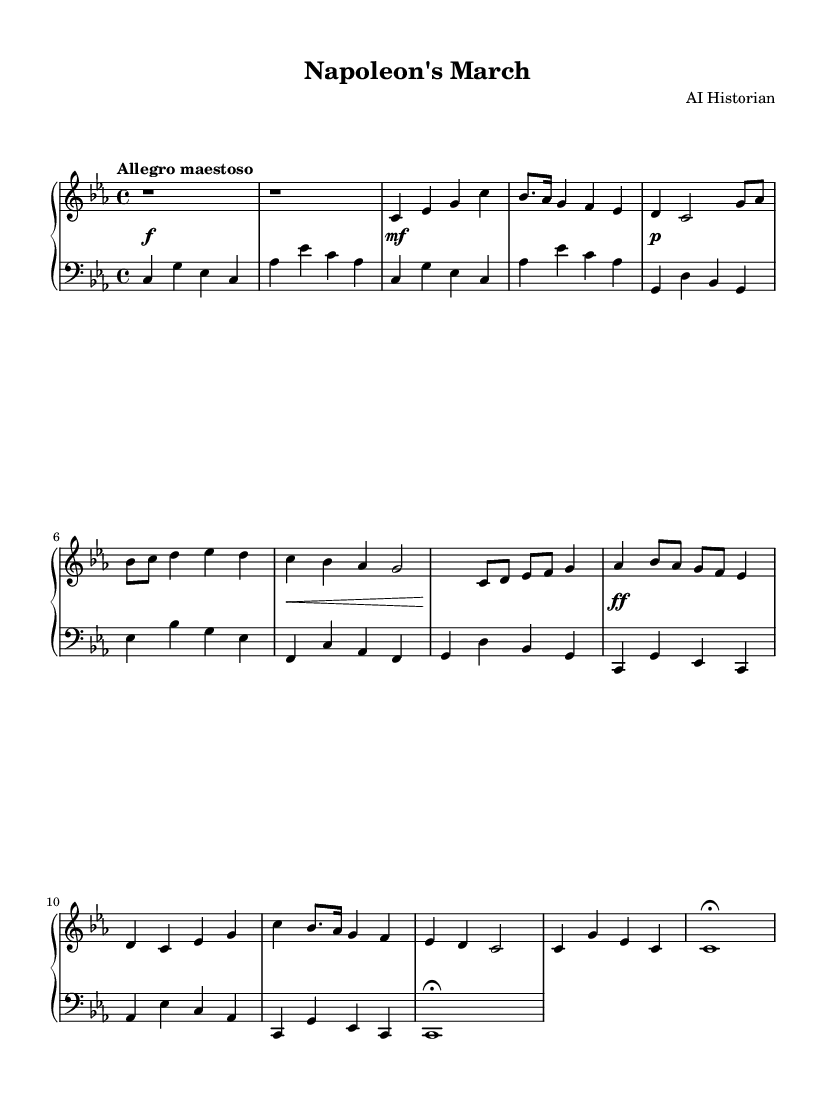What is the key signature of this music? The key signature is C minor, which has three flats: B flat, E flat, and A flat.
Answer: C minor What is the time signature of this composition? The time signature is 4/4, indicating that there are four beats per measure and the quarter note receives one beat.
Answer: 4/4 What is the indicated tempo marking for this piece? The tempo marking is "Allegro maestoso," which signifies a fast and stately pace.
Answer: Allegro maestoso How many themes are presented in the score? There are two distinct themes presented: the main theme and the secondary theme.
Answer: Two In which section does the development of the themes occur? The development occurs after the secondary theme and is characterized by the transformation and exploration of musical ideas.
Answer: Development What dynamic marking is used before the recapitulation of the main theme? The dynamic marking before the recapitulation indicates a forte, suggesting a strong and powerful return of the theme.
Answer: Forte What is the final texture of the piece when concluded? The piece concludes with a sustained tonic chord, indicated by a fermata, which signifies a pause or hold on that chord.
Answer: Fermata 